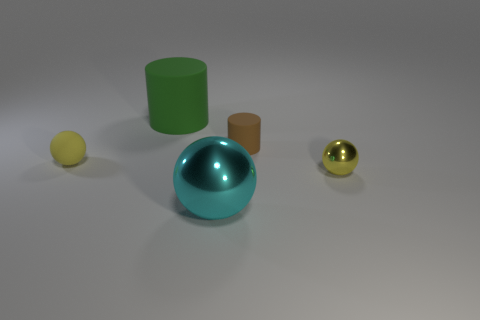Add 1 big red things. How many objects exist? 6 Subtract all cylinders. How many objects are left? 3 Subtract all red matte spheres. Subtract all tiny yellow balls. How many objects are left? 3 Add 2 small objects. How many small objects are left? 5 Add 2 big metal things. How many big metal things exist? 3 Subtract 0 red balls. How many objects are left? 5 